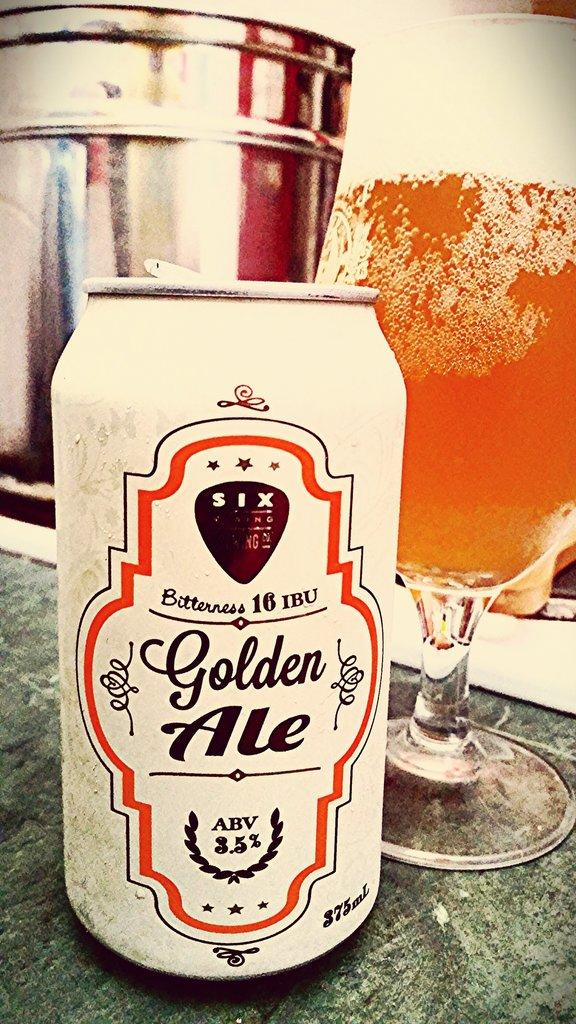<image>
Relay a brief, clear account of the picture shown. A cream-colored can of Six brand Golden Ale sits atop a table in front of a poured glass of beer. 